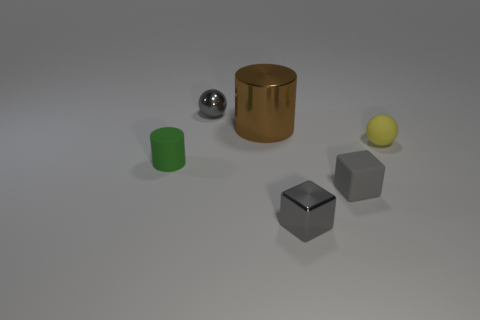There is a tiny yellow matte thing; are there any green cylinders behind it?
Ensure brevity in your answer.  No. What number of things are objects that are behind the tiny green rubber cylinder or gray things behind the metallic block?
Your response must be concise. 4. How many other shiny blocks are the same color as the tiny shiny cube?
Keep it short and to the point. 0. The shiny thing that is the same shape as the gray rubber object is what color?
Provide a short and direct response. Gray. There is a object that is both behind the yellow object and on the left side of the big thing; what shape is it?
Offer a terse response. Sphere. Is the number of big purple metal balls greater than the number of yellow matte objects?
Provide a succinct answer. No. What material is the large brown thing?
Ensure brevity in your answer.  Metal. Is there any other thing that is the same size as the green rubber cylinder?
Your answer should be compact. Yes. What size is the other object that is the same shape as the large brown thing?
Your response must be concise. Small. There is a tiny gray cube left of the tiny gray matte object; are there any metallic cubes that are right of it?
Ensure brevity in your answer.  No. 